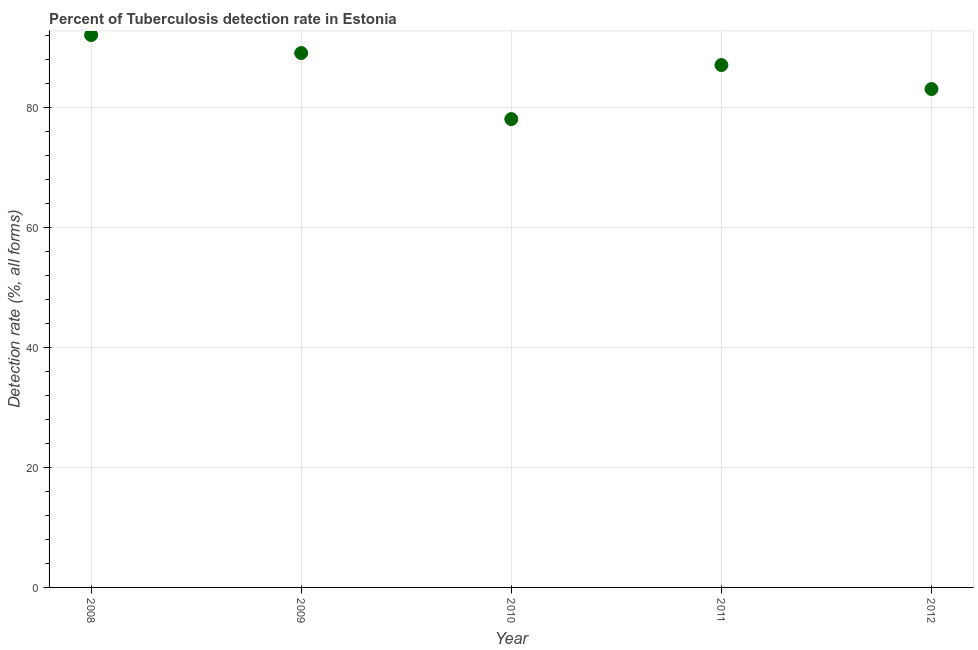What is the detection rate of tuberculosis in 2012?
Give a very brief answer. 83. Across all years, what is the maximum detection rate of tuberculosis?
Offer a terse response. 92. Across all years, what is the minimum detection rate of tuberculosis?
Offer a very short reply. 78. In which year was the detection rate of tuberculosis maximum?
Your response must be concise. 2008. In which year was the detection rate of tuberculosis minimum?
Offer a terse response. 2010. What is the sum of the detection rate of tuberculosis?
Make the answer very short. 429. What is the average detection rate of tuberculosis per year?
Provide a short and direct response. 85.8. Do a majority of the years between 2012 and 2011 (inclusive) have detection rate of tuberculosis greater than 32 %?
Your answer should be very brief. No. What is the ratio of the detection rate of tuberculosis in 2008 to that in 2010?
Provide a succinct answer. 1.18. What is the difference between the highest and the second highest detection rate of tuberculosis?
Make the answer very short. 3. Is the sum of the detection rate of tuberculosis in 2011 and 2012 greater than the maximum detection rate of tuberculosis across all years?
Your answer should be compact. Yes. What is the difference between the highest and the lowest detection rate of tuberculosis?
Your answer should be compact. 14. What is the difference between two consecutive major ticks on the Y-axis?
Make the answer very short. 20. Are the values on the major ticks of Y-axis written in scientific E-notation?
Your answer should be compact. No. What is the title of the graph?
Your answer should be very brief. Percent of Tuberculosis detection rate in Estonia. What is the label or title of the X-axis?
Offer a very short reply. Year. What is the label or title of the Y-axis?
Provide a short and direct response. Detection rate (%, all forms). What is the Detection rate (%, all forms) in 2008?
Ensure brevity in your answer.  92. What is the Detection rate (%, all forms) in 2009?
Your answer should be very brief. 89. What is the Detection rate (%, all forms) in 2012?
Give a very brief answer. 83. What is the difference between the Detection rate (%, all forms) in 2008 and 2009?
Give a very brief answer. 3. What is the difference between the Detection rate (%, all forms) in 2008 and 2010?
Provide a succinct answer. 14. What is the difference between the Detection rate (%, all forms) in 2008 and 2012?
Provide a succinct answer. 9. What is the difference between the Detection rate (%, all forms) in 2009 and 2010?
Ensure brevity in your answer.  11. What is the difference between the Detection rate (%, all forms) in 2009 and 2011?
Offer a very short reply. 2. What is the difference between the Detection rate (%, all forms) in 2010 and 2011?
Ensure brevity in your answer.  -9. What is the ratio of the Detection rate (%, all forms) in 2008 to that in 2009?
Make the answer very short. 1.03. What is the ratio of the Detection rate (%, all forms) in 2008 to that in 2010?
Your answer should be very brief. 1.18. What is the ratio of the Detection rate (%, all forms) in 2008 to that in 2011?
Provide a succinct answer. 1.06. What is the ratio of the Detection rate (%, all forms) in 2008 to that in 2012?
Your answer should be very brief. 1.11. What is the ratio of the Detection rate (%, all forms) in 2009 to that in 2010?
Offer a very short reply. 1.14. What is the ratio of the Detection rate (%, all forms) in 2009 to that in 2011?
Your answer should be compact. 1.02. What is the ratio of the Detection rate (%, all forms) in 2009 to that in 2012?
Your answer should be compact. 1.07. What is the ratio of the Detection rate (%, all forms) in 2010 to that in 2011?
Provide a succinct answer. 0.9. What is the ratio of the Detection rate (%, all forms) in 2010 to that in 2012?
Provide a succinct answer. 0.94. What is the ratio of the Detection rate (%, all forms) in 2011 to that in 2012?
Your answer should be very brief. 1.05. 